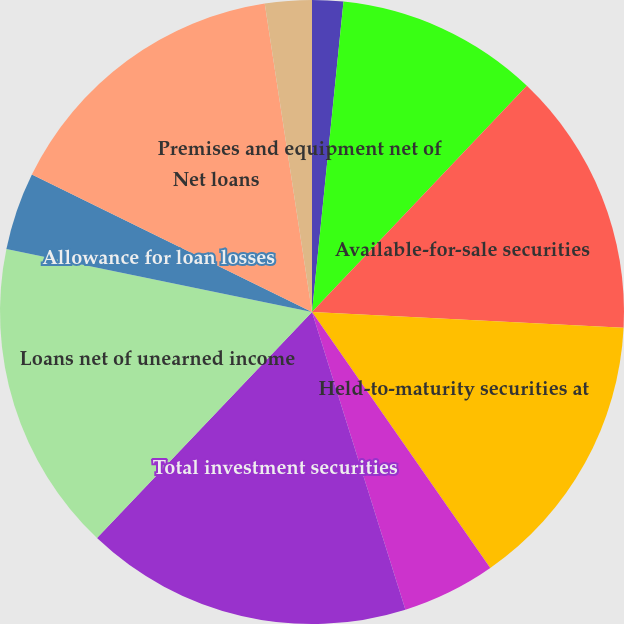Convert chart to OTSL. <chart><loc_0><loc_0><loc_500><loc_500><pie_chart><fcel>(Dollars in thousands except<fcel>Cash and cash equivalents<fcel>Available-for-sale securities<fcel>Held-to-maturity securities at<fcel>Non-marketable and other<fcel>Total investment securities<fcel>Loans net of unearned income<fcel>Allowance for loan losses<fcel>Net loans<fcel>Premises and equipment net of<nl><fcel>1.61%<fcel>10.48%<fcel>13.71%<fcel>14.52%<fcel>4.84%<fcel>16.94%<fcel>16.13%<fcel>4.03%<fcel>15.32%<fcel>2.42%<nl></chart> 